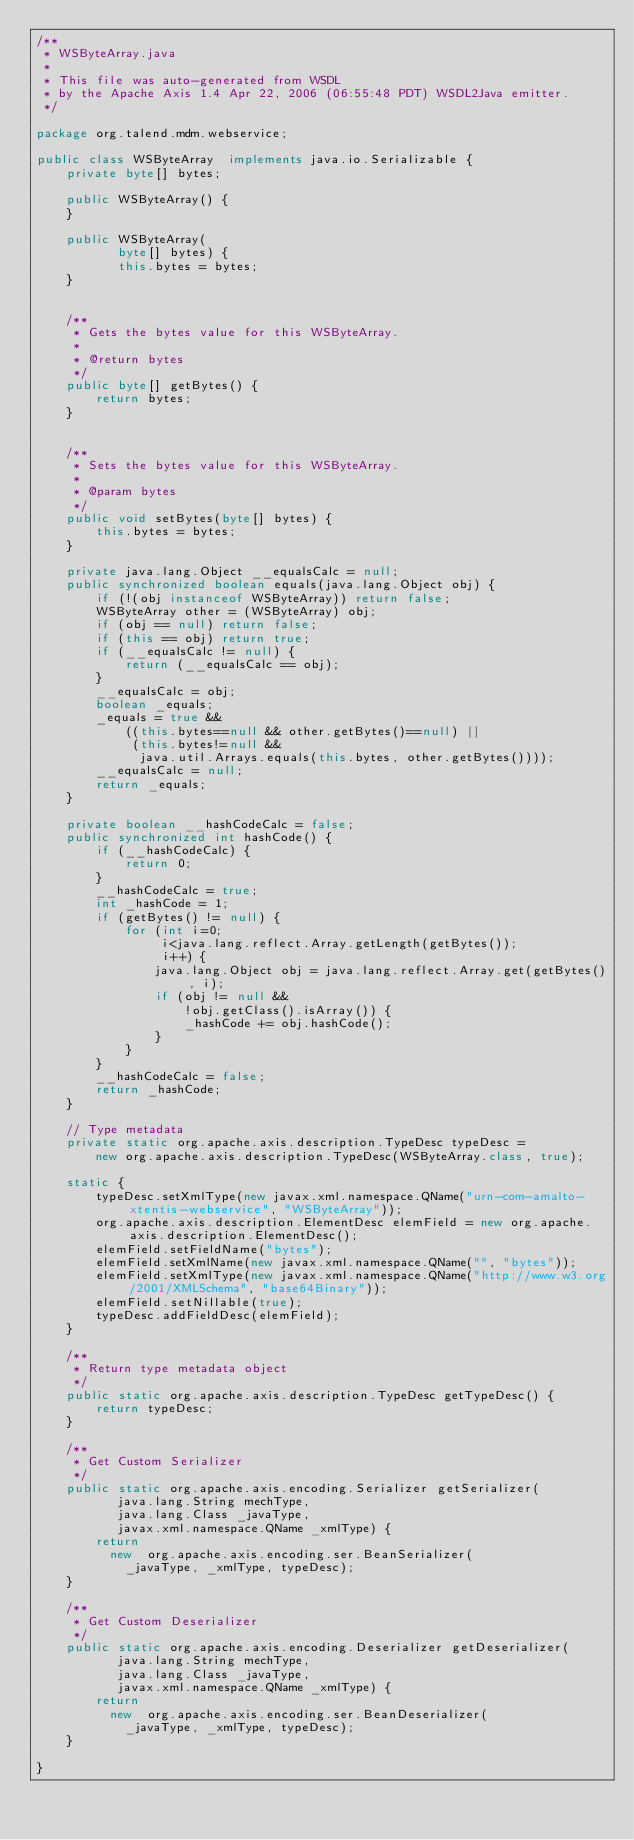Convert code to text. <code><loc_0><loc_0><loc_500><loc_500><_Java_>/**
 * WSByteArray.java
 *
 * This file was auto-generated from WSDL
 * by the Apache Axis 1.4 Apr 22, 2006 (06:55:48 PDT) WSDL2Java emitter.
 */

package org.talend.mdm.webservice;

public class WSByteArray  implements java.io.Serializable {
    private byte[] bytes;

    public WSByteArray() {
    }

    public WSByteArray(
           byte[] bytes) {
           this.bytes = bytes;
    }


    /**
     * Gets the bytes value for this WSByteArray.
     * 
     * @return bytes
     */
    public byte[] getBytes() {
        return bytes;
    }


    /**
     * Sets the bytes value for this WSByteArray.
     * 
     * @param bytes
     */
    public void setBytes(byte[] bytes) {
        this.bytes = bytes;
    }

    private java.lang.Object __equalsCalc = null;
    public synchronized boolean equals(java.lang.Object obj) {
        if (!(obj instanceof WSByteArray)) return false;
        WSByteArray other = (WSByteArray) obj;
        if (obj == null) return false;
        if (this == obj) return true;
        if (__equalsCalc != null) {
            return (__equalsCalc == obj);
        }
        __equalsCalc = obj;
        boolean _equals;
        _equals = true && 
            ((this.bytes==null && other.getBytes()==null) || 
             (this.bytes!=null &&
              java.util.Arrays.equals(this.bytes, other.getBytes())));
        __equalsCalc = null;
        return _equals;
    }

    private boolean __hashCodeCalc = false;
    public synchronized int hashCode() {
        if (__hashCodeCalc) {
            return 0;
        }
        __hashCodeCalc = true;
        int _hashCode = 1;
        if (getBytes() != null) {
            for (int i=0;
                 i<java.lang.reflect.Array.getLength(getBytes());
                 i++) {
                java.lang.Object obj = java.lang.reflect.Array.get(getBytes(), i);
                if (obj != null &&
                    !obj.getClass().isArray()) {
                    _hashCode += obj.hashCode();
                }
            }
        }
        __hashCodeCalc = false;
        return _hashCode;
    }

    // Type metadata
    private static org.apache.axis.description.TypeDesc typeDesc =
        new org.apache.axis.description.TypeDesc(WSByteArray.class, true);

    static {
        typeDesc.setXmlType(new javax.xml.namespace.QName("urn-com-amalto-xtentis-webservice", "WSByteArray"));
        org.apache.axis.description.ElementDesc elemField = new org.apache.axis.description.ElementDesc();
        elemField.setFieldName("bytes");
        elemField.setXmlName(new javax.xml.namespace.QName("", "bytes"));
        elemField.setXmlType(new javax.xml.namespace.QName("http://www.w3.org/2001/XMLSchema", "base64Binary"));
        elemField.setNillable(true);
        typeDesc.addFieldDesc(elemField);
    }

    /**
     * Return type metadata object
     */
    public static org.apache.axis.description.TypeDesc getTypeDesc() {
        return typeDesc;
    }

    /**
     * Get Custom Serializer
     */
    public static org.apache.axis.encoding.Serializer getSerializer(
           java.lang.String mechType, 
           java.lang.Class _javaType,  
           javax.xml.namespace.QName _xmlType) {
        return 
          new  org.apache.axis.encoding.ser.BeanSerializer(
            _javaType, _xmlType, typeDesc);
    }

    /**
     * Get Custom Deserializer
     */
    public static org.apache.axis.encoding.Deserializer getDeserializer(
           java.lang.String mechType, 
           java.lang.Class _javaType,  
           javax.xml.namespace.QName _xmlType) {
        return 
          new  org.apache.axis.encoding.ser.BeanDeserializer(
            _javaType, _xmlType, typeDesc);
    }

}
</code> 